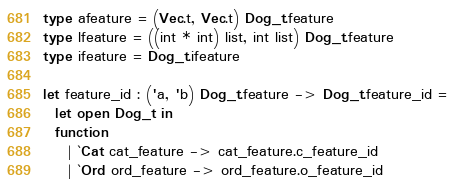<code> <loc_0><loc_0><loc_500><loc_500><_OCaml_>type afeature = (Vec.t, Vec.t) Dog_t.feature
type lfeature = ((int * int) list, int list) Dog_t.feature
type ifeature = Dog_t.ifeature

let feature_id : ('a, 'b) Dog_t.feature -> Dog_t.feature_id =
  let open Dog_t in
  function
    | `Cat cat_feature -> cat_feature.c_feature_id
    | `Ord ord_feature -> ord_feature.o_feature_id
</code> 